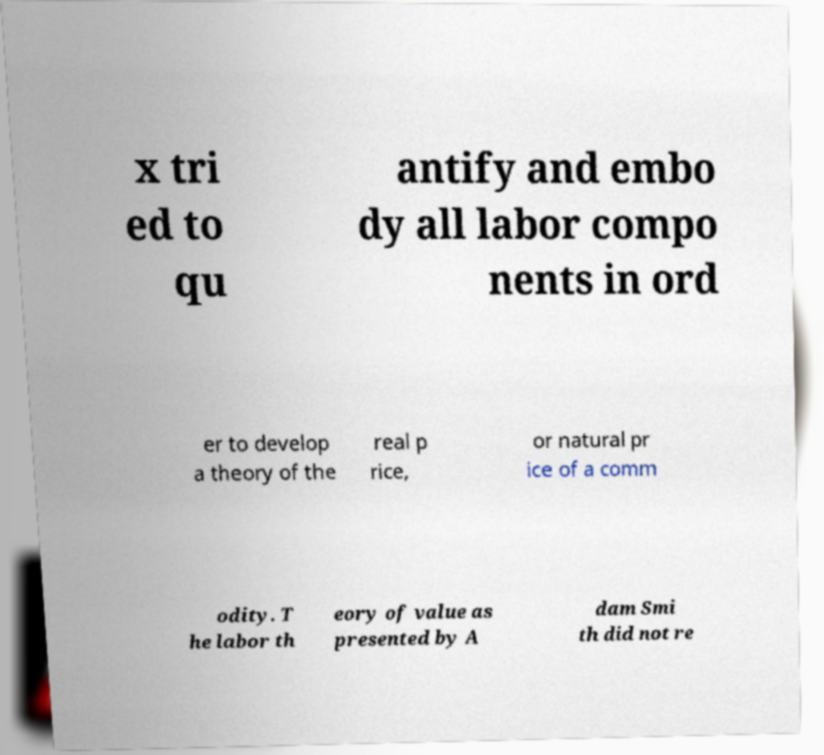Could you assist in decoding the text presented in this image and type it out clearly? x tri ed to qu antify and embo dy all labor compo nents in ord er to develop a theory of the real p rice, or natural pr ice of a comm odity. T he labor th eory of value as presented by A dam Smi th did not re 